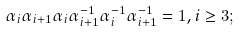Convert formula to latex. <formula><loc_0><loc_0><loc_500><loc_500>\alpha _ { i } \alpha _ { i + 1 } \alpha _ { i } \alpha _ { i + 1 } ^ { - 1 } \alpha _ { i } ^ { - 1 } \alpha _ { i + 1 } ^ { - 1 } = 1 , i \geq 3 ;</formula> 